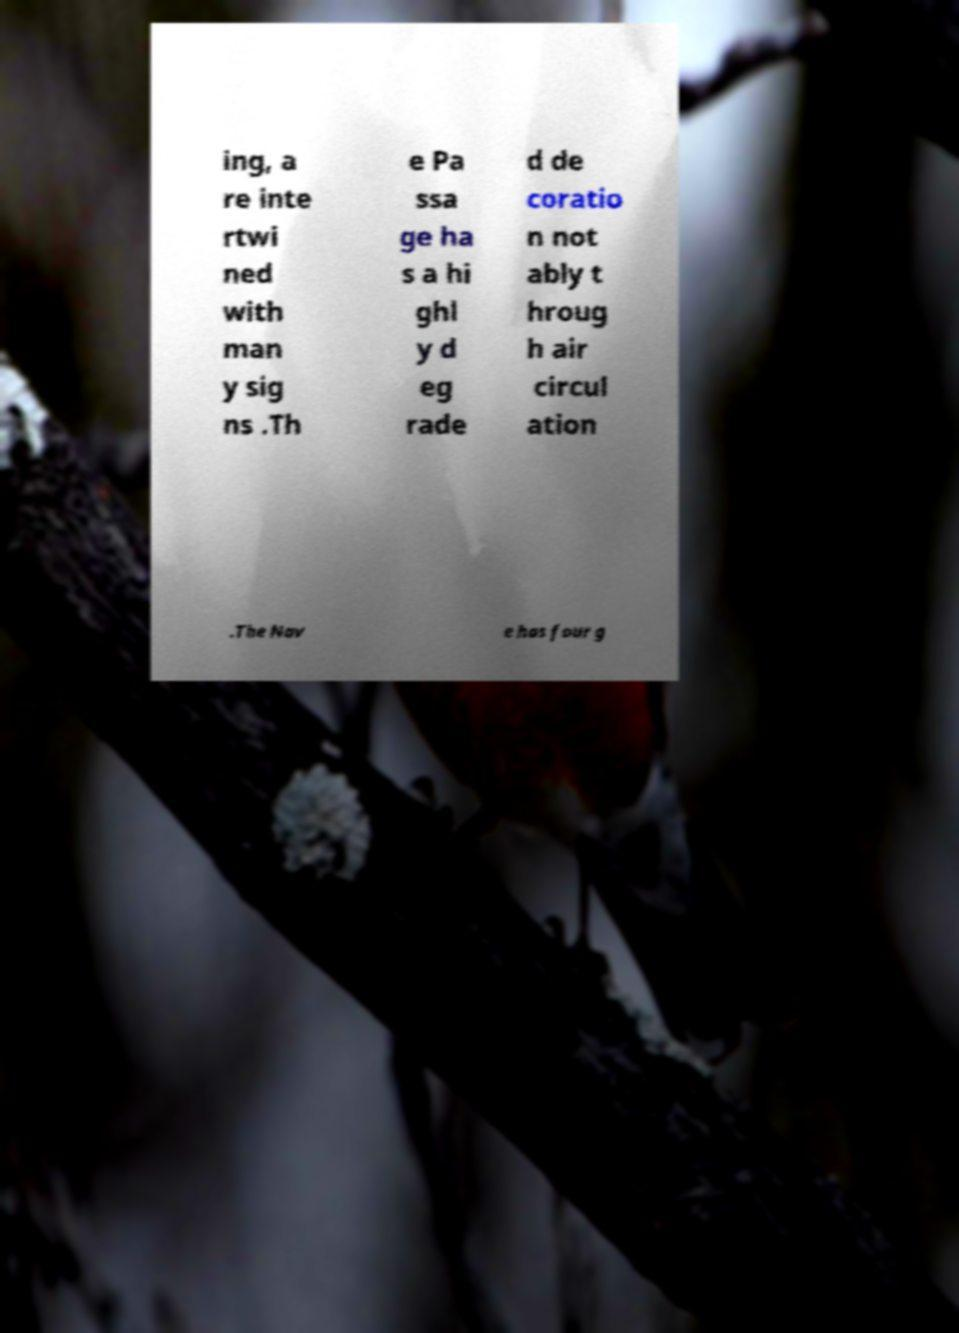Could you assist in decoding the text presented in this image and type it out clearly? ing, a re inte rtwi ned with man y sig ns .Th e Pa ssa ge ha s a hi ghl y d eg rade d de coratio n not ably t hroug h air circul ation .The Nav e has four g 